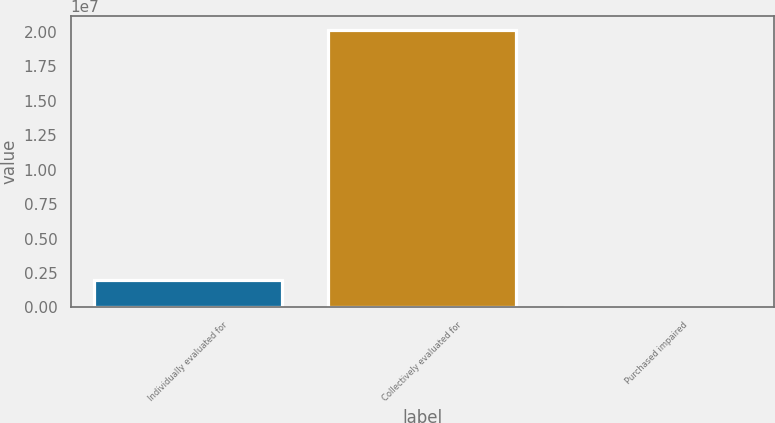Convert chart. <chart><loc_0><loc_0><loc_500><loc_500><bar_chart><fcel>Individually evaluated for<fcel>Collectively evaluated for<fcel>Purchased impaired<nl><fcel>2.01653e+06<fcel>2.01482e+07<fcel>1902<nl></chart> 